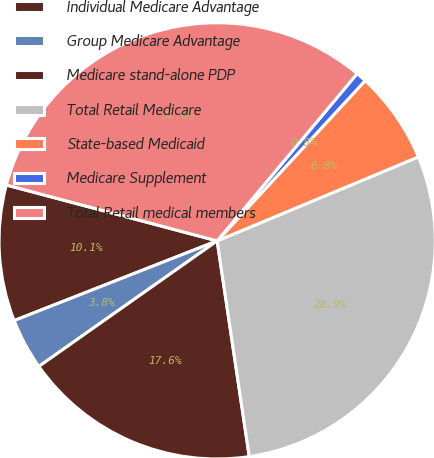<chart> <loc_0><loc_0><loc_500><loc_500><pie_chart><fcel>Individual Medicare Advantage<fcel>Group Medicare Advantage<fcel>Medicare stand-alone PDP<fcel>Total Retail Medicare<fcel>State-based Medicaid<fcel>Medicare Supplement<fcel>Total Retail medical members<nl><fcel>10.08%<fcel>3.81%<fcel>17.59%<fcel>28.94%<fcel>6.84%<fcel>0.78%<fcel>31.97%<nl></chart> 